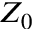Convert formula to latex. <formula><loc_0><loc_0><loc_500><loc_500>Z _ { 0 }</formula> 